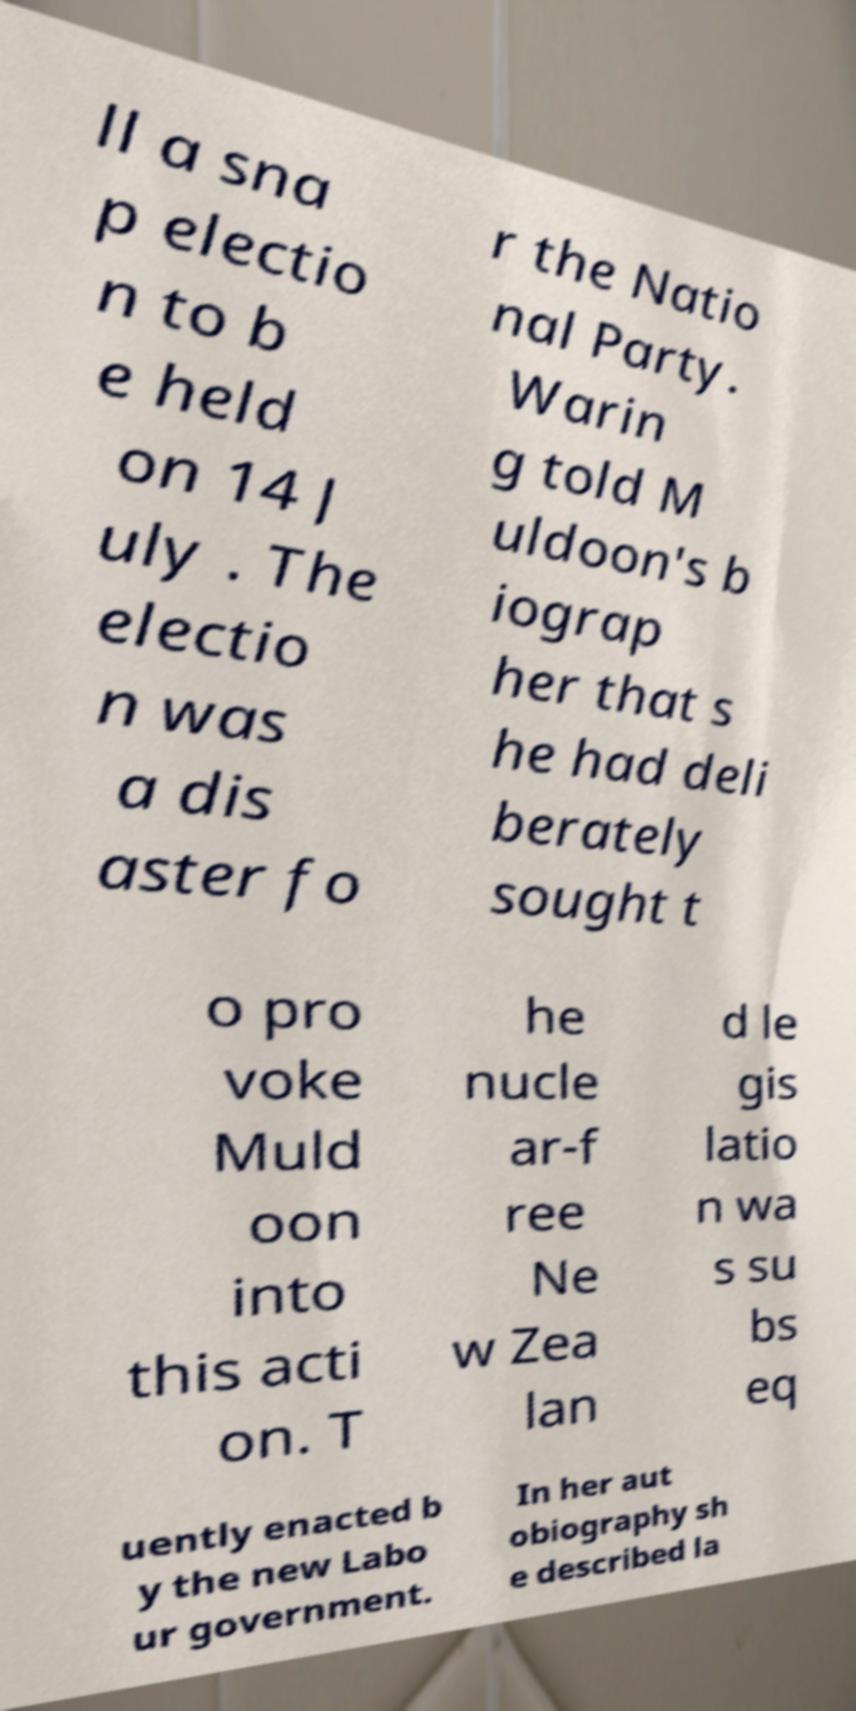Could you extract and type out the text from this image? ll a sna p electio n to b e held on 14 J uly . The electio n was a dis aster fo r the Natio nal Party. Warin g told M uldoon's b iograp her that s he had deli berately sought t o pro voke Muld oon into this acti on. T he nucle ar-f ree Ne w Zea lan d le gis latio n wa s su bs eq uently enacted b y the new Labo ur government. In her aut obiography sh e described la 